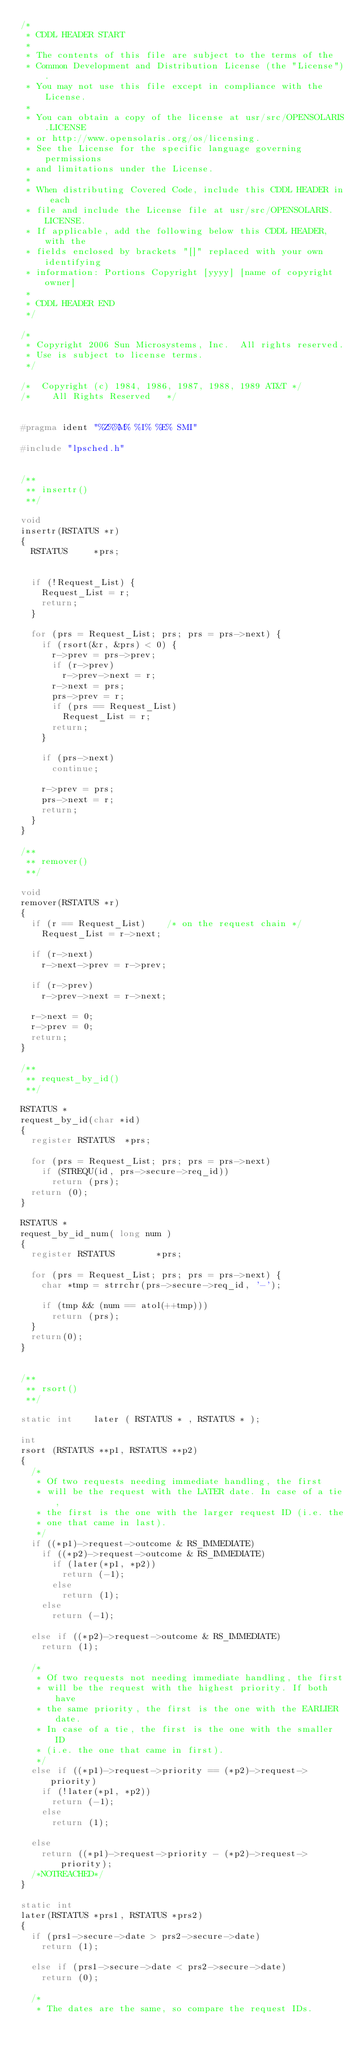<code> <loc_0><loc_0><loc_500><loc_500><_C_>/*
 * CDDL HEADER START
 *
 * The contents of this file are subject to the terms of the
 * Common Development and Distribution License (the "License").
 * You may not use this file except in compliance with the License.
 *
 * You can obtain a copy of the license at usr/src/OPENSOLARIS.LICENSE
 * or http://www.opensolaris.org/os/licensing.
 * See the License for the specific language governing permissions
 * and limitations under the License.
 *
 * When distributing Covered Code, include this CDDL HEADER in each
 * file and include the License file at usr/src/OPENSOLARIS.LICENSE.
 * If applicable, add the following below this CDDL HEADER, with the
 * fields enclosed by brackets "[]" replaced with your own identifying
 * information: Portions Copyright [yyyy] [name of copyright owner]
 *
 * CDDL HEADER END
 */

/*
 * Copyright 2006 Sun Microsystems, Inc.  All rights reserved.
 * Use is subject to license terms.
 */

/*	Copyright (c) 1984, 1986, 1987, 1988, 1989 AT&T	*/
/*	  All Rights Reserved  	*/


#pragma ident	"%Z%%M%	%I%	%E% SMI"

#include "lpsched.h"


/**
 ** insertr()
 **/

void
insertr(RSTATUS *r)
{
	RSTATUS			*prs;


	if (!Request_List) {
		Request_List = r;
		return;
	}
	
	for (prs = Request_List; prs; prs = prs->next) {
		if (rsort(&r, &prs) < 0) {
			r->prev = prs->prev;
			if (r->prev)
				r->prev->next = r;
			r->next = prs;
			prs->prev = r;
			if (prs == Request_List)
				Request_List = r;
			return;
		}

		if (prs->next)
			continue;

		r->prev = prs;
		prs->next = r;
		return;
	}
}

/**
 ** remover()
 **/

void
remover(RSTATUS *r)
{
	if (r == Request_List)		/* on the request chain */
		Request_List = r->next;
	
	if (r->next)
		r->next->prev = r->prev;
	
	if (r->prev)
		r->prev->next = r->next;
	
	r->next = 0;
	r->prev = 0;
	return;
}

/**
 ** request_by_id()
 **/

RSTATUS *
request_by_id(char *id)
{
	register RSTATUS	*prs;
	
	for (prs = Request_List; prs; prs = prs->next)
		if (STREQU(id, prs->secure->req_id))
			return (prs);
	return (0);
}

RSTATUS *
request_by_id_num( long num )
{
	register RSTATUS        *prs;

	for (prs = Request_List; prs; prs = prs->next) {
		char *tmp = strrchr(prs->secure->req_id, '-');

		if (tmp && (num == atol(++tmp)))
			return (prs);
	}
	return(0);
}


/**
 ** rsort()
 **/

static int		later ( RSTATUS * , RSTATUS * );

int
rsort (RSTATUS **p1, RSTATUS **p2)
{
	/*
	 * Of two requests needing immediate handling, the first
	 * will be the request with the LATER date. In case of a tie,
	 * the first is the one with the larger request ID (i.e. the
	 * one that came in last).
	 */
	if ((*p1)->request->outcome & RS_IMMEDIATE)
		if ((*p2)->request->outcome & RS_IMMEDIATE)
			if (later(*p1, *p2))
				return (-1);
			else
				return (1);
		else
			return (-1);

	else if ((*p2)->request->outcome & RS_IMMEDIATE)
		return (1);

	/*
	 * Of two requests not needing immediate handling, the first
	 * will be the request with the highest priority. If both have
	 * the same priority, the first is the one with the EARLIER date.
	 * In case of a tie, the first is the one with the smaller ID
	 * (i.e. the one that came in first).
	 */
	else if ((*p1)->request->priority == (*p2)->request->priority)
		if (!later(*p1, *p2))
			return (-1);
		else
			return (1);

	else
		return ((*p1)->request->priority - (*p2)->request->priority);
	/*NOTREACHED*/
}

static int
later(RSTATUS *prs1, RSTATUS *prs2)
{
	if (prs1->secure->date > prs2->secure->date)
		return (1);

	else if (prs1->secure->date < prs2->secure->date)
		return (0);

	/*
	 * The dates are the same, so compare the request IDs.</code> 